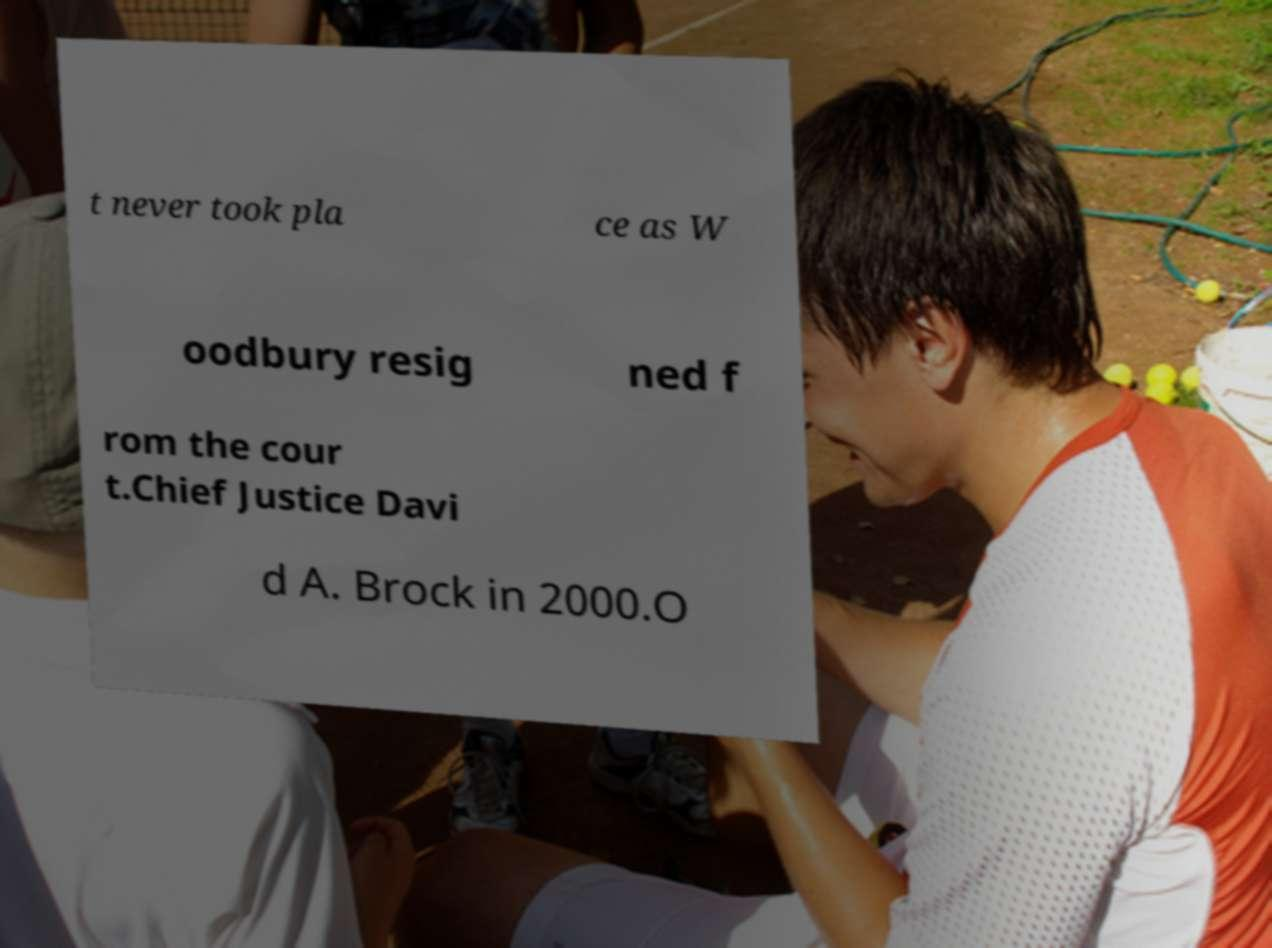Could you assist in decoding the text presented in this image and type it out clearly? t never took pla ce as W oodbury resig ned f rom the cour t.Chief Justice Davi d A. Brock in 2000.O 